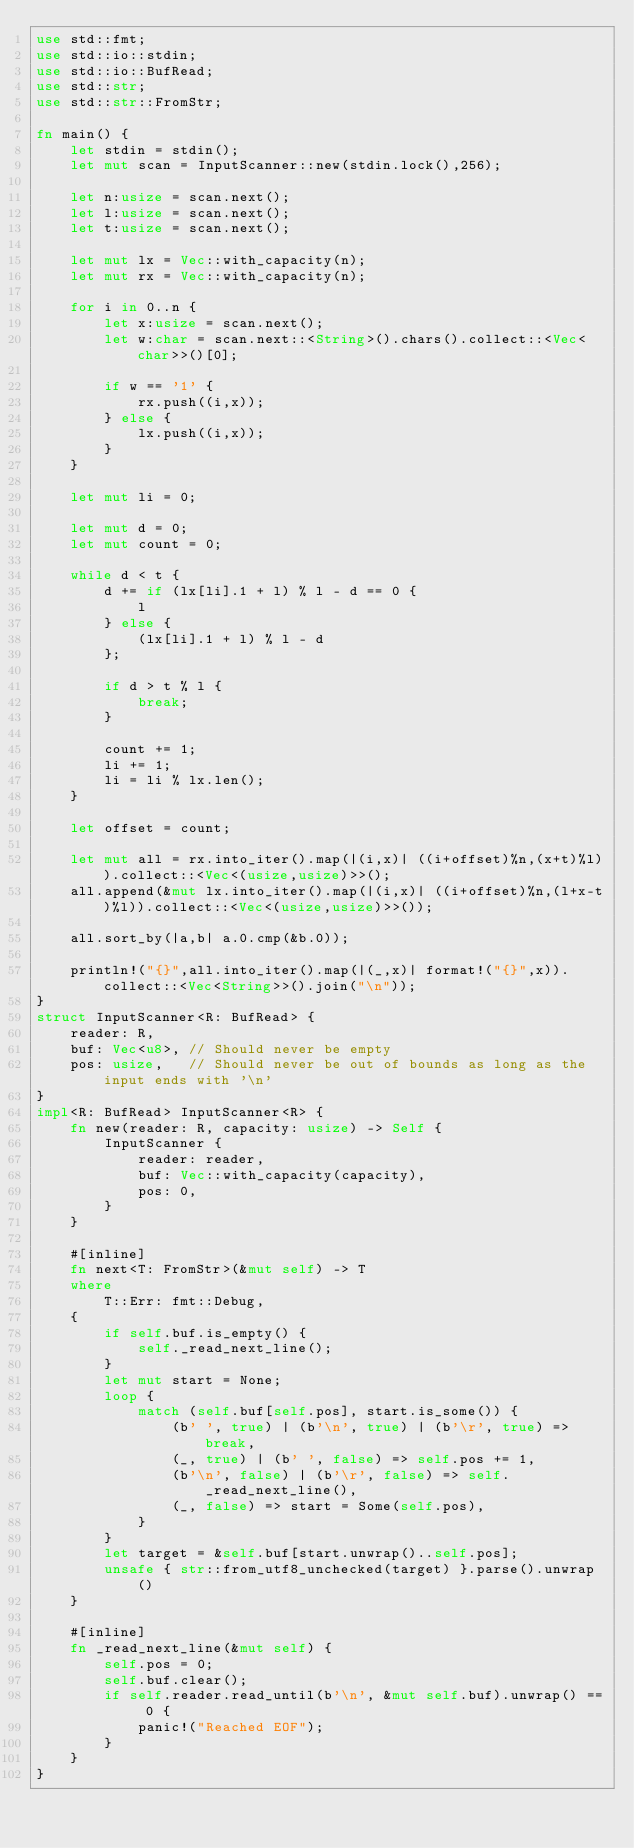<code> <loc_0><loc_0><loc_500><loc_500><_Rust_>use std::fmt;
use std::io::stdin;
use std::io::BufRead;
use std::str;
use std::str::FromStr;

fn main() {
	let stdin = stdin();
	let mut scan = InputScanner::new(stdin.lock(),256);

	let n:usize = scan.next();
	let l:usize = scan.next();
	let t:usize = scan.next();

	let mut lx = Vec::with_capacity(n);
	let mut rx = Vec::with_capacity(n);

	for i in 0..n {
		let x:usize = scan.next();
		let w:char = scan.next::<String>().chars().collect::<Vec<char>>()[0];

		if w == '1' {
			rx.push((i,x));
		} else {
			lx.push((i,x));
		}
	}

	let mut li = 0;

	let mut d = 0;
	let mut count = 0;

	while d < t {
		d += if (lx[li].1 + l) % l - d == 0 {
			l
		} else {
			(lx[li].1 + l) % l - d
		};

		if d > t % l {
			break;
		}

		count += 1;
		li += 1;
		li = li % lx.len();
	}

	let offset = count;

	let mut all = rx.into_iter().map(|(i,x)| ((i+offset)%n,(x+t)%l)).collect::<Vec<(usize,usize)>>();
	all.append(&mut lx.into_iter().map(|(i,x)| ((i+offset)%n,(l+x-t)%l)).collect::<Vec<(usize,usize)>>());

	all.sort_by(|a,b| a.0.cmp(&b.0));

	println!("{}",all.into_iter().map(|(_,x)| format!("{}",x)).collect::<Vec<String>>().join("\n"));
}
struct InputScanner<R: BufRead> {
	reader: R,
	buf: Vec<u8>, // Should never be empty
	pos: usize,   // Should never be out of bounds as long as the input ends with '\n'
}
impl<R: BufRead> InputScanner<R> {
	fn new(reader: R, capacity: usize) -> Self {
		InputScanner {
			reader: reader,
			buf: Vec::with_capacity(capacity),
			pos: 0,
		}
	}

	#[inline]
	fn next<T: FromStr>(&mut self) -> T
	where
		T::Err: fmt::Debug,
	{
		if self.buf.is_empty() {
			self._read_next_line();
		}
		let mut start = None;
		loop {
			match (self.buf[self.pos], start.is_some()) {
				(b' ', true) | (b'\n', true) | (b'\r', true) => break,
				(_, true) | (b' ', false) => self.pos += 1,
				(b'\n', false) | (b'\r', false) => self._read_next_line(),
				(_, false) => start = Some(self.pos),
			}
		}
		let target = &self.buf[start.unwrap()..self.pos];
		unsafe { str::from_utf8_unchecked(target) }.parse().unwrap()
	}

	#[inline]
	fn _read_next_line(&mut self) {
		self.pos = 0;
		self.buf.clear();
		if self.reader.read_until(b'\n', &mut self.buf).unwrap() == 0 {
			panic!("Reached EOF");
		}
	}
}

</code> 